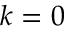<formula> <loc_0><loc_0><loc_500><loc_500>k = 0</formula> 